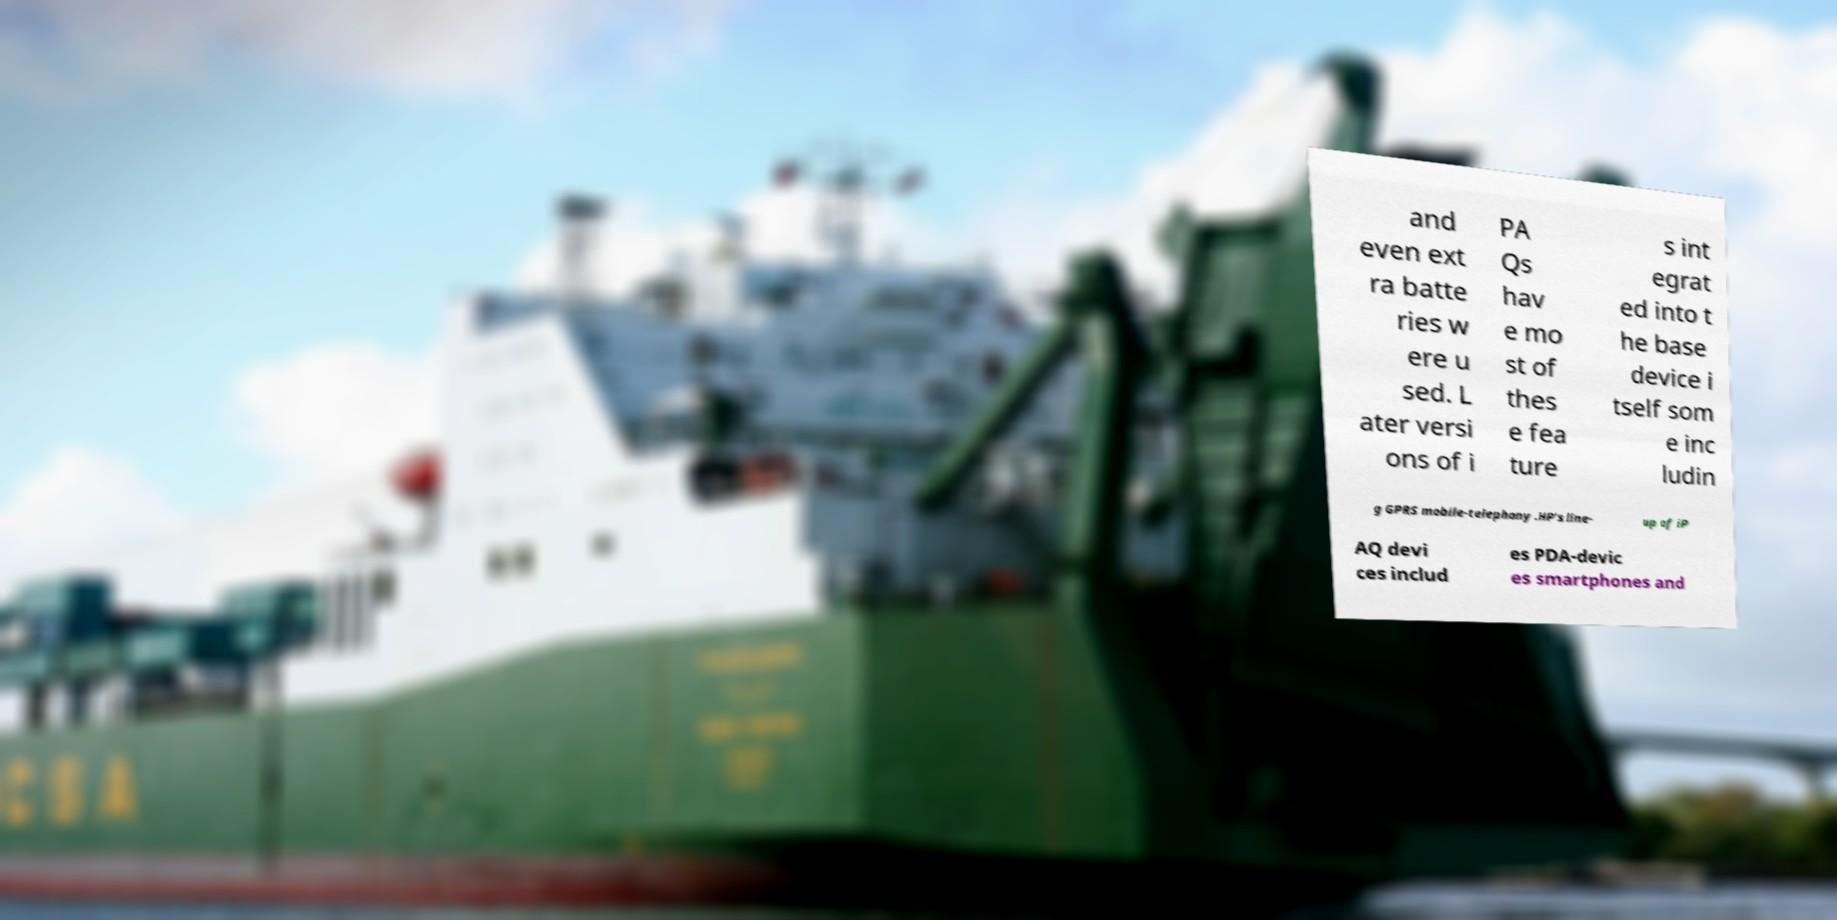For documentation purposes, I need the text within this image transcribed. Could you provide that? and even ext ra batte ries w ere u sed. L ater versi ons of i PA Qs hav e mo st of thes e fea ture s int egrat ed into t he base device i tself som e inc ludin g GPRS mobile-telephony .HP's line- up of iP AQ devi ces includ es PDA-devic es smartphones and 